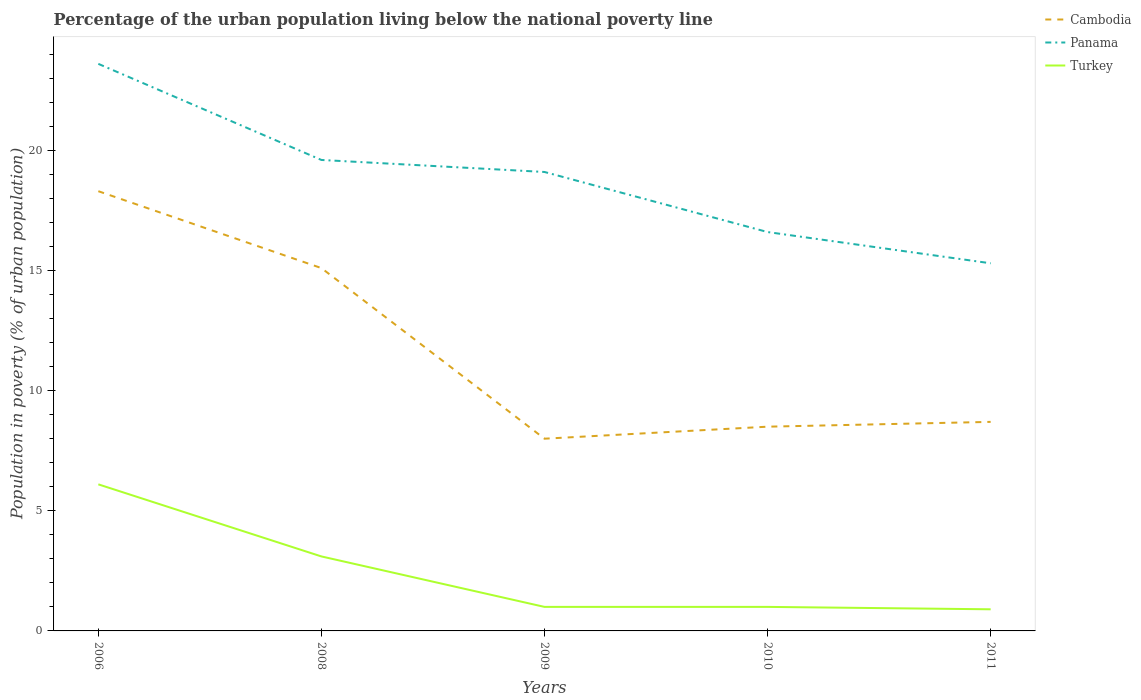How many different coloured lines are there?
Provide a succinct answer. 3. Across all years, what is the maximum percentage of the urban population living below the national poverty line in Panama?
Offer a very short reply. 15.3. What is the total percentage of the urban population living below the national poverty line in Turkey in the graph?
Your answer should be compact. 0.1. What is the difference between the highest and the second highest percentage of the urban population living below the national poverty line in Panama?
Make the answer very short. 8.3. What is the difference between the highest and the lowest percentage of the urban population living below the national poverty line in Panama?
Offer a terse response. 3. How many lines are there?
Your answer should be very brief. 3. Are the values on the major ticks of Y-axis written in scientific E-notation?
Keep it short and to the point. No. Does the graph contain grids?
Keep it short and to the point. No. Where does the legend appear in the graph?
Keep it short and to the point. Top right. How many legend labels are there?
Your answer should be very brief. 3. What is the title of the graph?
Make the answer very short. Percentage of the urban population living below the national poverty line. What is the label or title of the Y-axis?
Keep it short and to the point. Population in poverty (% of urban population). What is the Population in poverty (% of urban population) in Cambodia in 2006?
Make the answer very short. 18.3. What is the Population in poverty (% of urban population) in Panama in 2006?
Your response must be concise. 23.6. What is the Population in poverty (% of urban population) in Turkey in 2006?
Your response must be concise. 6.1. What is the Population in poverty (% of urban population) of Panama in 2008?
Your answer should be compact. 19.6. What is the Population in poverty (% of urban population) in Cambodia in 2009?
Provide a short and direct response. 8. What is the Population in poverty (% of urban population) in Panama in 2009?
Keep it short and to the point. 19.1. What is the Population in poverty (% of urban population) in Cambodia in 2010?
Your answer should be very brief. 8.5. What is the Population in poverty (% of urban population) of Panama in 2010?
Ensure brevity in your answer.  16.6. Across all years, what is the maximum Population in poverty (% of urban population) of Panama?
Your response must be concise. 23.6. Across all years, what is the maximum Population in poverty (% of urban population) of Turkey?
Offer a very short reply. 6.1. Across all years, what is the minimum Population in poverty (% of urban population) in Panama?
Offer a terse response. 15.3. What is the total Population in poverty (% of urban population) in Cambodia in the graph?
Keep it short and to the point. 58.6. What is the total Population in poverty (% of urban population) of Panama in the graph?
Make the answer very short. 94.2. What is the total Population in poverty (% of urban population) in Turkey in the graph?
Give a very brief answer. 12.1. What is the difference between the Population in poverty (% of urban population) of Cambodia in 2006 and that in 2008?
Provide a succinct answer. 3.2. What is the difference between the Population in poverty (% of urban population) in Panama in 2006 and that in 2008?
Provide a short and direct response. 4. What is the difference between the Population in poverty (% of urban population) of Turkey in 2006 and that in 2010?
Offer a very short reply. 5.1. What is the difference between the Population in poverty (% of urban population) of Panama in 2006 and that in 2011?
Your response must be concise. 8.3. What is the difference between the Population in poverty (% of urban population) of Turkey in 2006 and that in 2011?
Offer a very short reply. 5.2. What is the difference between the Population in poverty (% of urban population) of Cambodia in 2008 and that in 2009?
Provide a short and direct response. 7.1. What is the difference between the Population in poverty (% of urban population) of Turkey in 2008 and that in 2009?
Ensure brevity in your answer.  2.1. What is the difference between the Population in poverty (% of urban population) in Cambodia in 2009 and that in 2010?
Offer a terse response. -0.5. What is the difference between the Population in poverty (% of urban population) in Panama in 2009 and that in 2010?
Provide a short and direct response. 2.5. What is the difference between the Population in poverty (% of urban population) in Panama in 2009 and that in 2011?
Your answer should be very brief. 3.8. What is the difference between the Population in poverty (% of urban population) of Panama in 2010 and that in 2011?
Your answer should be compact. 1.3. What is the difference between the Population in poverty (% of urban population) of Cambodia in 2006 and the Population in poverty (% of urban population) of Panama in 2008?
Give a very brief answer. -1.3. What is the difference between the Population in poverty (% of urban population) of Cambodia in 2006 and the Population in poverty (% of urban population) of Turkey in 2008?
Ensure brevity in your answer.  15.2. What is the difference between the Population in poverty (% of urban population) in Panama in 2006 and the Population in poverty (% of urban population) in Turkey in 2008?
Ensure brevity in your answer.  20.5. What is the difference between the Population in poverty (% of urban population) of Cambodia in 2006 and the Population in poverty (% of urban population) of Panama in 2009?
Provide a short and direct response. -0.8. What is the difference between the Population in poverty (% of urban population) in Cambodia in 2006 and the Population in poverty (% of urban population) in Turkey in 2009?
Your answer should be very brief. 17.3. What is the difference between the Population in poverty (% of urban population) of Panama in 2006 and the Population in poverty (% of urban population) of Turkey in 2009?
Provide a succinct answer. 22.6. What is the difference between the Population in poverty (% of urban population) in Panama in 2006 and the Population in poverty (% of urban population) in Turkey in 2010?
Offer a very short reply. 22.6. What is the difference between the Population in poverty (% of urban population) of Panama in 2006 and the Population in poverty (% of urban population) of Turkey in 2011?
Offer a terse response. 22.7. What is the difference between the Population in poverty (% of urban population) of Panama in 2008 and the Population in poverty (% of urban population) of Turkey in 2009?
Your answer should be very brief. 18.6. What is the difference between the Population in poverty (% of urban population) in Cambodia in 2008 and the Population in poverty (% of urban population) in Turkey in 2010?
Provide a short and direct response. 14.1. What is the difference between the Population in poverty (% of urban population) in Cambodia in 2008 and the Population in poverty (% of urban population) in Panama in 2011?
Offer a very short reply. -0.2. What is the difference between the Population in poverty (% of urban population) in Cambodia in 2008 and the Population in poverty (% of urban population) in Turkey in 2011?
Your response must be concise. 14.2. What is the difference between the Population in poverty (% of urban population) in Panama in 2008 and the Population in poverty (% of urban population) in Turkey in 2011?
Ensure brevity in your answer.  18.7. What is the difference between the Population in poverty (% of urban population) of Cambodia in 2009 and the Population in poverty (% of urban population) of Turkey in 2010?
Offer a very short reply. 7. What is the difference between the Population in poverty (% of urban population) of Cambodia in 2009 and the Population in poverty (% of urban population) of Panama in 2011?
Ensure brevity in your answer.  -7.3. What is the difference between the Population in poverty (% of urban population) in Cambodia in 2009 and the Population in poverty (% of urban population) in Turkey in 2011?
Offer a terse response. 7.1. What is the difference between the Population in poverty (% of urban population) of Panama in 2009 and the Population in poverty (% of urban population) of Turkey in 2011?
Your answer should be very brief. 18.2. What is the difference between the Population in poverty (% of urban population) of Cambodia in 2010 and the Population in poverty (% of urban population) of Turkey in 2011?
Offer a very short reply. 7.6. What is the average Population in poverty (% of urban population) in Cambodia per year?
Offer a very short reply. 11.72. What is the average Population in poverty (% of urban population) in Panama per year?
Give a very brief answer. 18.84. What is the average Population in poverty (% of urban population) in Turkey per year?
Ensure brevity in your answer.  2.42. In the year 2009, what is the difference between the Population in poverty (% of urban population) in Cambodia and Population in poverty (% of urban population) in Panama?
Provide a succinct answer. -11.1. In the year 2009, what is the difference between the Population in poverty (% of urban population) in Panama and Population in poverty (% of urban population) in Turkey?
Provide a short and direct response. 18.1. In the year 2010, what is the difference between the Population in poverty (% of urban population) of Cambodia and Population in poverty (% of urban population) of Panama?
Provide a succinct answer. -8.1. In the year 2010, what is the difference between the Population in poverty (% of urban population) of Panama and Population in poverty (% of urban population) of Turkey?
Offer a very short reply. 15.6. What is the ratio of the Population in poverty (% of urban population) in Cambodia in 2006 to that in 2008?
Keep it short and to the point. 1.21. What is the ratio of the Population in poverty (% of urban population) of Panama in 2006 to that in 2008?
Provide a succinct answer. 1.2. What is the ratio of the Population in poverty (% of urban population) of Turkey in 2006 to that in 2008?
Ensure brevity in your answer.  1.97. What is the ratio of the Population in poverty (% of urban population) of Cambodia in 2006 to that in 2009?
Make the answer very short. 2.29. What is the ratio of the Population in poverty (% of urban population) in Panama in 2006 to that in 2009?
Your answer should be compact. 1.24. What is the ratio of the Population in poverty (% of urban population) of Turkey in 2006 to that in 2009?
Ensure brevity in your answer.  6.1. What is the ratio of the Population in poverty (% of urban population) of Cambodia in 2006 to that in 2010?
Your answer should be compact. 2.15. What is the ratio of the Population in poverty (% of urban population) in Panama in 2006 to that in 2010?
Your answer should be compact. 1.42. What is the ratio of the Population in poverty (% of urban population) in Turkey in 2006 to that in 2010?
Provide a succinct answer. 6.1. What is the ratio of the Population in poverty (% of urban population) of Cambodia in 2006 to that in 2011?
Make the answer very short. 2.1. What is the ratio of the Population in poverty (% of urban population) of Panama in 2006 to that in 2011?
Offer a terse response. 1.54. What is the ratio of the Population in poverty (% of urban population) of Turkey in 2006 to that in 2011?
Keep it short and to the point. 6.78. What is the ratio of the Population in poverty (% of urban population) of Cambodia in 2008 to that in 2009?
Provide a short and direct response. 1.89. What is the ratio of the Population in poverty (% of urban population) of Panama in 2008 to that in 2009?
Ensure brevity in your answer.  1.03. What is the ratio of the Population in poverty (% of urban population) of Cambodia in 2008 to that in 2010?
Your response must be concise. 1.78. What is the ratio of the Population in poverty (% of urban population) of Panama in 2008 to that in 2010?
Your answer should be compact. 1.18. What is the ratio of the Population in poverty (% of urban population) of Turkey in 2008 to that in 2010?
Your answer should be very brief. 3.1. What is the ratio of the Population in poverty (% of urban population) in Cambodia in 2008 to that in 2011?
Your answer should be very brief. 1.74. What is the ratio of the Population in poverty (% of urban population) in Panama in 2008 to that in 2011?
Your answer should be very brief. 1.28. What is the ratio of the Population in poverty (% of urban population) of Turkey in 2008 to that in 2011?
Your response must be concise. 3.44. What is the ratio of the Population in poverty (% of urban population) in Cambodia in 2009 to that in 2010?
Give a very brief answer. 0.94. What is the ratio of the Population in poverty (% of urban population) in Panama in 2009 to that in 2010?
Your response must be concise. 1.15. What is the ratio of the Population in poverty (% of urban population) of Turkey in 2009 to that in 2010?
Provide a short and direct response. 1. What is the ratio of the Population in poverty (% of urban population) of Cambodia in 2009 to that in 2011?
Give a very brief answer. 0.92. What is the ratio of the Population in poverty (% of urban population) of Panama in 2009 to that in 2011?
Give a very brief answer. 1.25. What is the ratio of the Population in poverty (% of urban population) of Panama in 2010 to that in 2011?
Offer a terse response. 1.08. What is the ratio of the Population in poverty (% of urban population) of Turkey in 2010 to that in 2011?
Offer a very short reply. 1.11. What is the difference between the highest and the lowest Population in poverty (% of urban population) of Panama?
Your response must be concise. 8.3. 